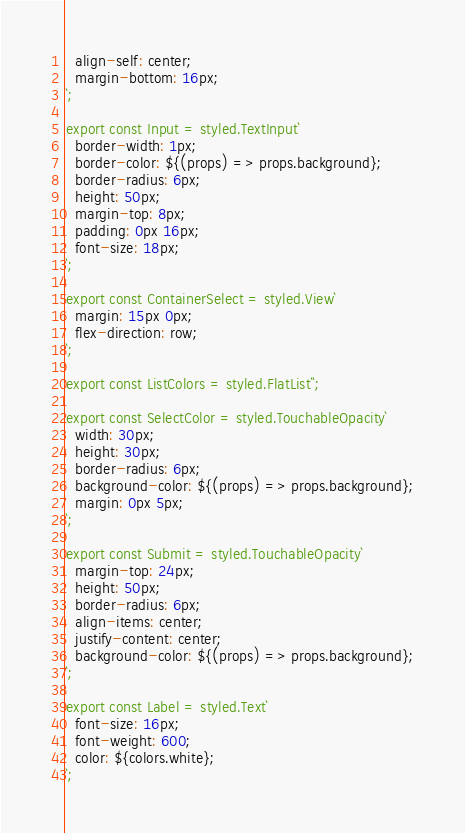Convert code to text. <code><loc_0><loc_0><loc_500><loc_500><_JavaScript_>  align-self: center;
  margin-bottom: 16px;
`;

export const Input = styled.TextInput`
  border-width: 1px;
  border-color: ${(props) => props.background};
  border-radius: 6px;
  height: 50px;
  margin-top: 8px;
  padding: 0px 16px;
  font-size: 18px;
`;

export const ContainerSelect = styled.View`
  margin: 15px 0px;
  flex-direction: row;
`;

export const ListColors = styled.FlatList``;

export const SelectColor = styled.TouchableOpacity`
  width: 30px;
  height: 30px;
  border-radius: 6px;
  background-color: ${(props) => props.background};
  margin: 0px 5px;
`;

export const Submit = styled.TouchableOpacity`
  margin-top: 24px;
  height: 50px;
  border-radius: 6px;
  align-items: center;
  justify-content: center;
  background-color: ${(props) => props.background};
`;

export const Label = styled.Text`
  font-size: 16px;
  font-weight: 600;
  color: ${colors.white};
`;
</code> 